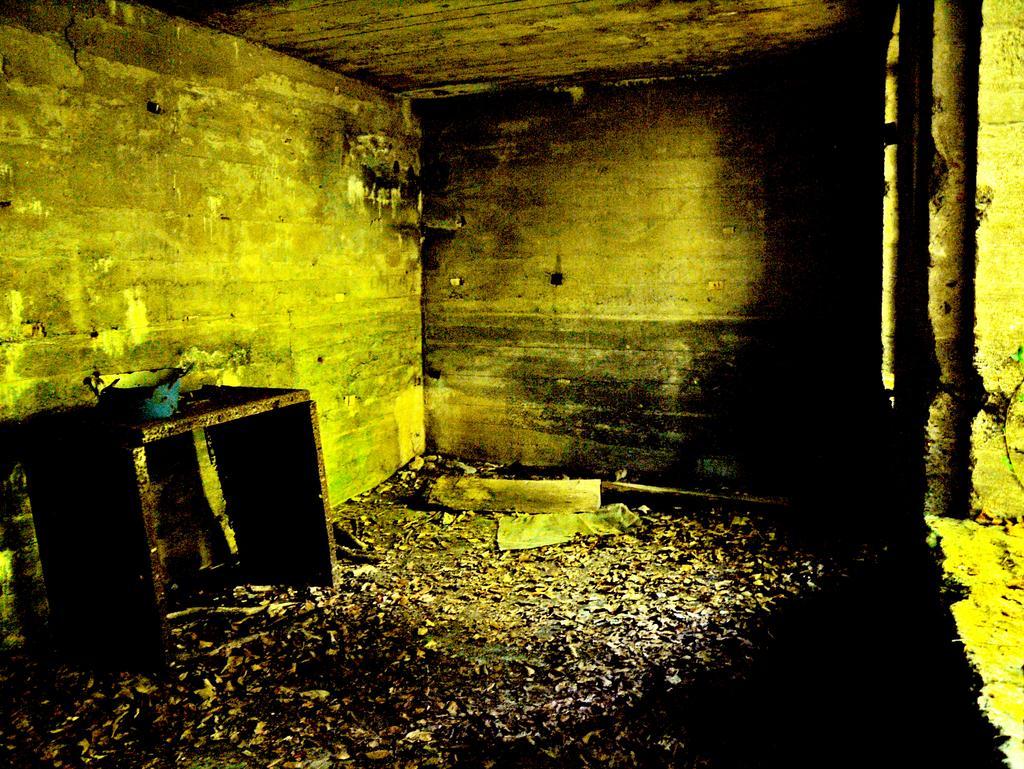Please provide a concise description of this image. In this image I can see the blue color object on the wooden surface. I can see many objects on the floor. In the background I can see the wall. 